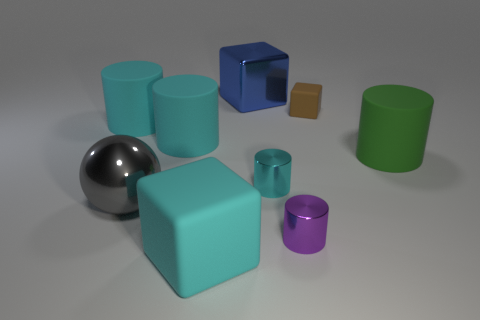How many purple objects are either tiny metallic cylinders or tiny objects?
Make the answer very short. 1. Is there a big cylinder of the same color as the large shiny sphere?
Make the answer very short. No. There is a brown block that is the same material as the large green cylinder; what is its size?
Your answer should be very brief. Small. How many cylinders are either large things or brown rubber objects?
Your answer should be compact. 3. Is the number of purple metal cylinders greater than the number of small green rubber things?
Provide a short and direct response. Yes. What number of purple shiny objects are the same size as the gray shiny sphere?
Provide a short and direct response. 0. There is a small shiny object that is the same color as the large matte block; what is its shape?
Your answer should be very brief. Cylinder. What number of objects are either matte blocks behind the gray metallic thing or tiny yellow rubber objects?
Provide a short and direct response. 1. Are there fewer large brown shiny things than big blue cubes?
Your response must be concise. Yes. The gray object that is made of the same material as the blue cube is what shape?
Ensure brevity in your answer.  Sphere. 